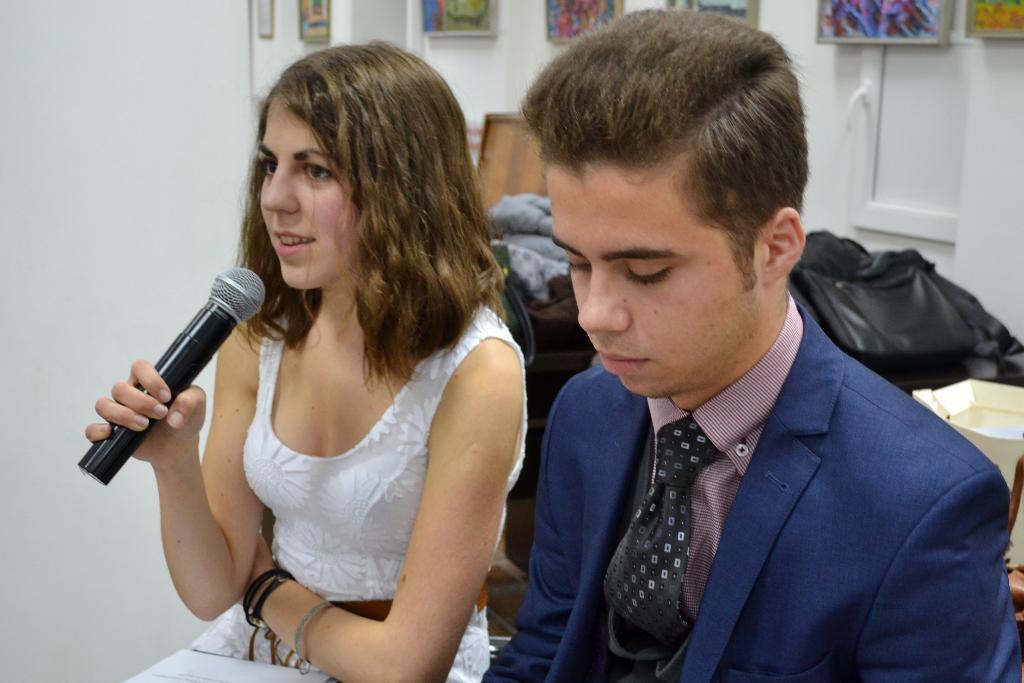How would you summarize this image in a sentence or two? This picture shows a man and a woman seated and we see a woman speaking with the help of a microphone and we see few photo frames on the wall. 